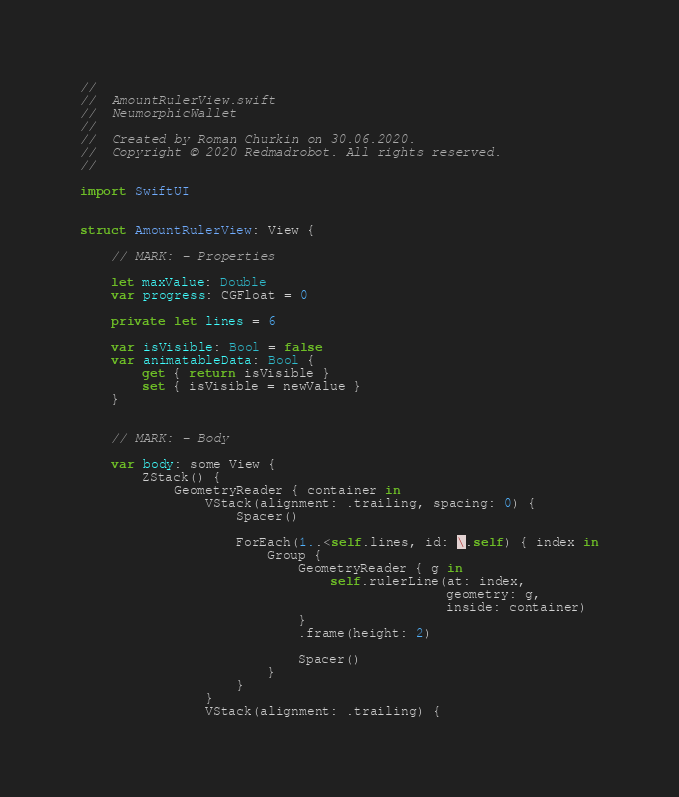Convert code to text. <code><loc_0><loc_0><loc_500><loc_500><_Swift_>//
//  AmountRulerView.swift
//  NeumorphicWallet
//
//  Created by Roman Churkin on 30.06.2020.
//  Copyright © 2020 Redmadrobot. All rights reserved.
//

import SwiftUI


struct AmountRulerView: View {
    
    // MARK: - Properties
    
    let maxValue: Double
    var progress: CGFloat = 0
    
    private let lines = 6
    
    var isVisible: Bool = false
    var animatableData: Bool {
        get { return isVisible }
        set { isVisible = newValue }
    }
    
    
    // MARK: - Body
    
    var body: some View {
        ZStack() {
            GeometryReader { container in
                VStack(alignment: .trailing, spacing: 0) {
                    Spacer()
                    
                    ForEach(1..<self.lines, id: \.self) { index in
                        Group {
                            GeometryReader { g in
                                self.rulerLine(at: index,
                                               geometry: g,
                                               inside: container)
                            }
                            .frame(height: 2)

                            Spacer()
                        }
                    }
                }
                VStack(alignment: .trailing) {</code> 